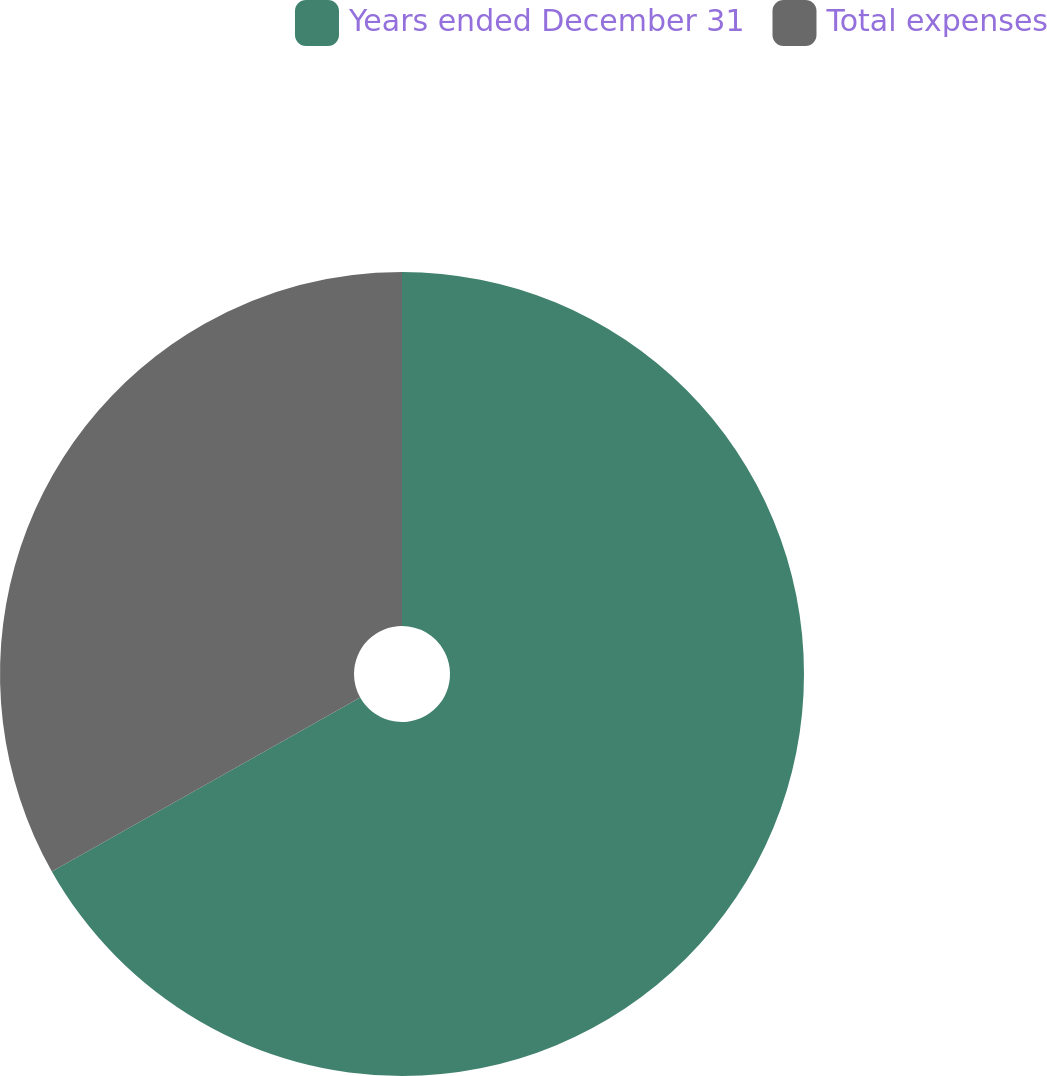<chart> <loc_0><loc_0><loc_500><loc_500><pie_chart><fcel>Years ended December 31<fcel>Total expenses<nl><fcel>66.83%<fcel>33.17%<nl></chart> 